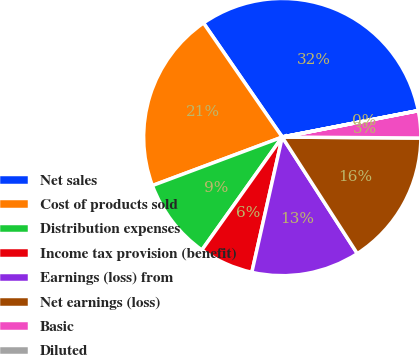Convert chart to OTSL. <chart><loc_0><loc_0><loc_500><loc_500><pie_chart><fcel>Net sales<fcel>Cost of products sold<fcel>Distribution expenses<fcel>Income tax provision (benefit)<fcel>Earnings (loss) from<fcel>Net earnings (loss)<fcel>Basic<fcel>Diluted<nl><fcel>31.56%<fcel>21.07%<fcel>9.47%<fcel>6.32%<fcel>12.63%<fcel>15.78%<fcel>3.16%<fcel>0.01%<nl></chart> 